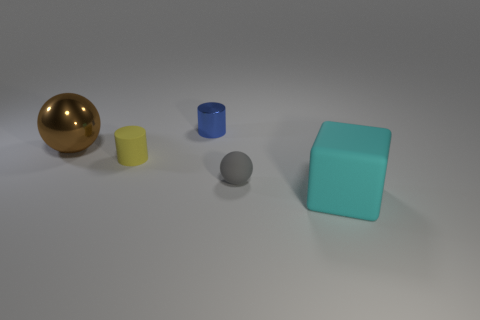What is the color of the matte object that is the same shape as the brown shiny object?
Provide a short and direct response. Gray. How many gray objects are there?
Provide a short and direct response. 1. How many shiny things are either large cyan cylinders or tiny objects?
Give a very brief answer. 1. There is a tiny cylinder that is behind the big object behind the large cyan thing; what is its material?
Ensure brevity in your answer.  Metal. The metal cylinder is what size?
Your answer should be compact. Small. How many cubes are the same size as the gray rubber object?
Keep it short and to the point. 0. How many large shiny things are the same shape as the yellow rubber thing?
Your answer should be compact. 0. Are there an equal number of small gray spheres that are on the left side of the tiny rubber sphere and large gray metallic objects?
Ensure brevity in your answer.  Yes. What is the shape of the cyan rubber object that is the same size as the metal ball?
Ensure brevity in your answer.  Cube. Are there any other big objects of the same shape as the yellow object?
Your answer should be very brief. No. 